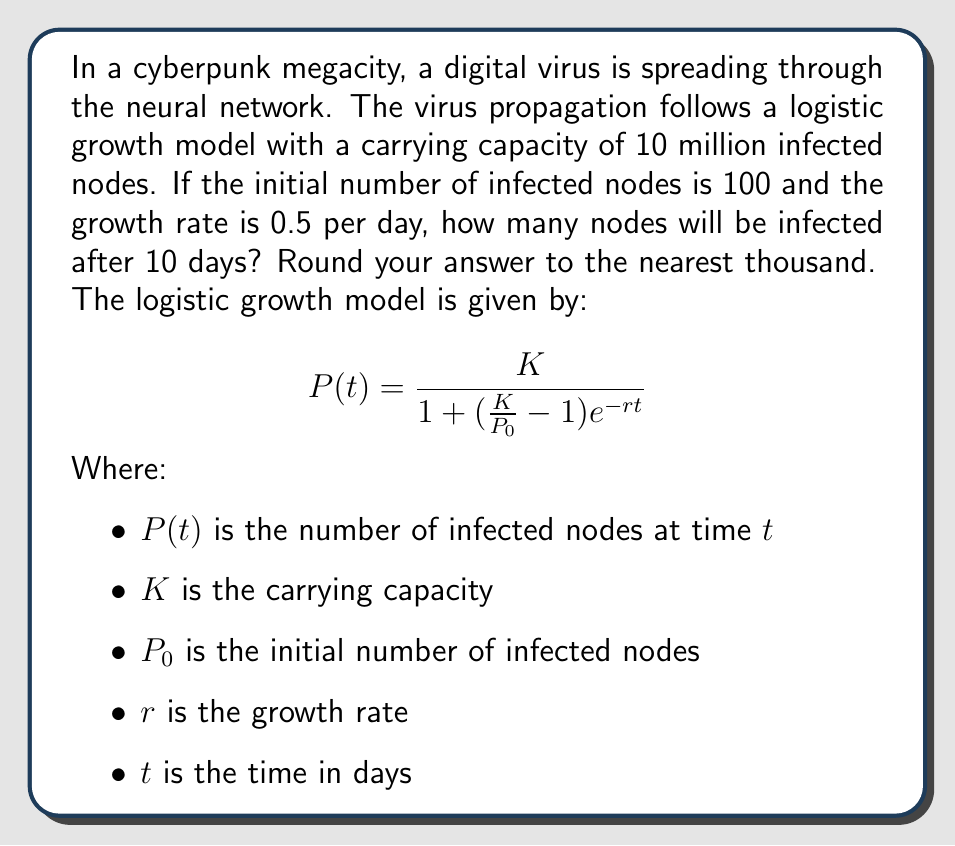Could you help me with this problem? To solve this problem, we need to use the logistic growth model equation and plug in the given values:

$K = 10,000,000$ (carrying capacity)
$P_0 = 100$ (initial infected nodes)
$r = 0.5$ (growth rate per day)
$t = 10$ (days)

Let's substitute these values into the equation:

$$P(10) = \frac{10,000,000}{1 + (\frac{10,000,000}{100} - 1)e^{-0.5 \cdot 10}}$$

Now, let's solve this step-by-step:

1. Simplify the fraction inside the parentheses:
   $$P(10) = \frac{10,000,000}{1 + (99,999)e^{-5}}$$

2. Calculate $e^{-5}$:
   $e^{-5} \approx 0.00673795$

3. Multiply this by 99,999:
   $99,999 \cdot 0.00673795 \approx 673.79$

4. Add 1 to this result:
   $1 + 673.79 = 674.79$

5. Divide 10,000,000 by this result:
   $$P(10) = \frac{10,000,000}{674.79} \approx 14,819.85$$

6. Round to the nearest thousand:
   $P(10) \approx 15,000$
Answer: 15,000 nodes 